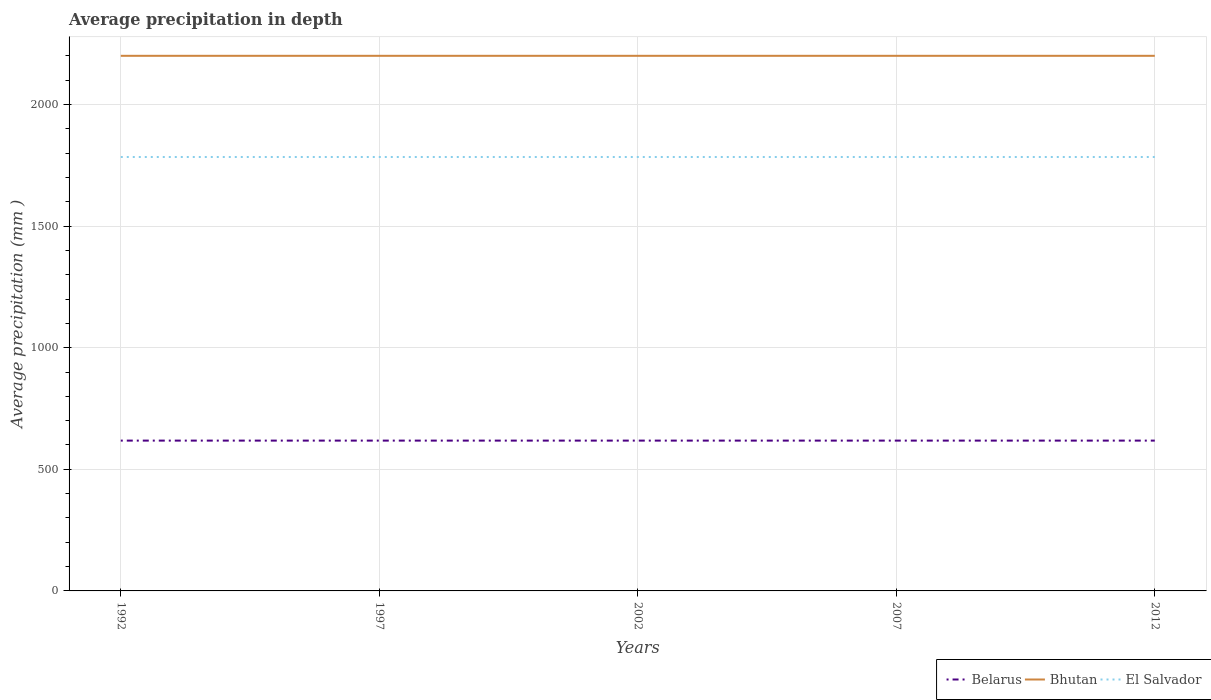Across all years, what is the maximum average precipitation in El Salvador?
Ensure brevity in your answer.  1784. What is the total average precipitation in Belarus in the graph?
Make the answer very short. 0. Is the average precipitation in El Salvador strictly greater than the average precipitation in Belarus over the years?
Your response must be concise. No. How many years are there in the graph?
Give a very brief answer. 5. What is the difference between two consecutive major ticks on the Y-axis?
Offer a terse response. 500. Are the values on the major ticks of Y-axis written in scientific E-notation?
Offer a very short reply. No. How many legend labels are there?
Your response must be concise. 3. How are the legend labels stacked?
Offer a very short reply. Horizontal. What is the title of the graph?
Keep it short and to the point. Average precipitation in depth. Does "Turkey" appear as one of the legend labels in the graph?
Your answer should be compact. No. What is the label or title of the X-axis?
Keep it short and to the point. Years. What is the label or title of the Y-axis?
Offer a very short reply. Average precipitation (mm ). What is the Average precipitation (mm ) of Belarus in 1992?
Offer a terse response. 618. What is the Average precipitation (mm ) of Bhutan in 1992?
Give a very brief answer. 2200. What is the Average precipitation (mm ) of El Salvador in 1992?
Provide a succinct answer. 1784. What is the Average precipitation (mm ) in Belarus in 1997?
Give a very brief answer. 618. What is the Average precipitation (mm ) in Bhutan in 1997?
Offer a very short reply. 2200. What is the Average precipitation (mm ) of El Salvador in 1997?
Ensure brevity in your answer.  1784. What is the Average precipitation (mm ) in Belarus in 2002?
Offer a terse response. 618. What is the Average precipitation (mm ) of Bhutan in 2002?
Your answer should be very brief. 2200. What is the Average precipitation (mm ) of El Salvador in 2002?
Make the answer very short. 1784. What is the Average precipitation (mm ) of Belarus in 2007?
Your answer should be compact. 618. What is the Average precipitation (mm ) in Bhutan in 2007?
Your answer should be very brief. 2200. What is the Average precipitation (mm ) in El Salvador in 2007?
Keep it short and to the point. 1784. What is the Average precipitation (mm ) of Belarus in 2012?
Offer a very short reply. 618. What is the Average precipitation (mm ) of Bhutan in 2012?
Your response must be concise. 2200. What is the Average precipitation (mm ) in El Salvador in 2012?
Provide a short and direct response. 1784. Across all years, what is the maximum Average precipitation (mm ) of Belarus?
Make the answer very short. 618. Across all years, what is the maximum Average precipitation (mm ) of Bhutan?
Keep it short and to the point. 2200. Across all years, what is the maximum Average precipitation (mm ) of El Salvador?
Offer a very short reply. 1784. Across all years, what is the minimum Average precipitation (mm ) of Belarus?
Your answer should be very brief. 618. Across all years, what is the minimum Average precipitation (mm ) of Bhutan?
Offer a very short reply. 2200. Across all years, what is the minimum Average precipitation (mm ) in El Salvador?
Give a very brief answer. 1784. What is the total Average precipitation (mm ) in Belarus in the graph?
Ensure brevity in your answer.  3090. What is the total Average precipitation (mm ) of Bhutan in the graph?
Give a very brief answer. 1.10e+04. What is the total Average precipitation (mm ) in El Salvador in the graph?
Ensure brevity in your answer.  8920. What is the difference between the Average precipitation (mm ) of Belarus in 1992 and that in 1997?
Your answer should be compact. 0. What is the difference between the Average precipitation (mm ) of Bhutan in 1992 and that in 1997?
Provide a short and direct response. 0. What is the difference between the Average precipitation (mm ) in Belarus in 1992 and that in 2002?
Your answer should be compact. 0. What is the difference between the Average precipitation (mm ) of El Salvador in 1992 and that in 2002?
Give a very brief answer. 0. What is the difference between the Average precipitation (mm ) in Belarus in 1992 and that in 2007?
Ensure brevity in your answer.  0. What is the difference between the Average precipitation (mm ) in El Salvador in 1992 and that in 2007?
Provide a succinct answer. 0. What is the difference between the Average precipitation (mm ) of El Salvador in 1992 and that in 2012?
Provide a succinct answer. 0. What is the difference between the Average precipitation (mm ) in El Salvador in 1997 and that in 2007?
Give a very brief answer. 0. What is the difference between the Average precipitation (mm ) in Belarus in 1997 and that in 2012?
Your answer should be very brief. 0. What is the difference between the Average precipitation (mm ) of El Salvador in 1997 and that in 2012?
Make the answer very short. 0. What is the difference between the Average precipitation (mm ) in Bhutan in 2002 and that in 2007?
Give a very brief answer. 0. What is the difference between the Average precipitation (mm ) of El Salvador in 2002 and that in 2007?
Your response must be concise. 0. What is the difference between the Average precipitation (mm ) in Belarus in 2002 and that in 2012?
Your answer should be compact. 0. What is the difference between the Average precipitation (mm ) in Bhutan in 2002 and that in 2012?
Your answer should be compact. 0. What is the difference between the Average precipitation (mm ) in Bhutan in 2007 and that in 2012?
Make the answer very short. 0. What is the difference between the Average precipitation (mm ) in El Salvador in 2007 and that in 2012?
Make the answer very short. 0. What is the difference between the Average precipitation (mm ) in Belarus in 1992 and the Average precipitation (mm ) in Bhutan in 1997?
Offer a terse response. -1582. What is the difference between the Average precipitation (mm ) of Belarus in 1992 and the Average precipitation (mm ) of El Salvador in 1997?
Give a very brief answer. -1166. What is the difference between the Average precipitation (mm ) of Bhutan in 1992 and the Average precipitation (mm ) of El Salvador in 1997?
Provide a short and direct response. 416. What is the difference between the Average precipitation (mm ) of Belarus in 1992 and the Average precipitation (mm ) of Bhutan in 2002?
Offer a terse response. -1582. What is the difference between the Average precipitation (mm ) of Belarus in 1992 and the Average precipitation (mm ) of El Salvador in 2002?
Provide a succinct answer. -1166. What is the difference between the Average precipitation (mm ) in Bhutan in 1992 and the Average precipitation (mm ) in El Salvador in 2002?
Your answer should be very brief. 416. What is the difference between the Average precipitation (mm ) of Belarus in 1992 and the Average precipitation (mm ) of Bhutan in 2007?
Your answer should be very brief. -1582. What is the difference between the Average precipitation (mm ) of Belarus in 1992 and the Average precipitation (mm ) of El Salvador in 2007?
Give a very brief answer. -1166. What is the difference between the Average precipitation (mm ) in Bhutan in 1992 and the Average precipitation (mm ) in El Salvador in 2007?
Provide a succinct answer. 416. What is the difference between the Average precipitation (mm ) in Belarus in 1992 and the Average precipitation (mm ) in Bhutan in 2012?
Make the answer very short. -1582. What is the difference between the Average precipitation (mm ) of Belarus in 1992 and the Average precipitation (mm ) of El Salvador in 2012?
Your response must be concise. -1166. What is the difference between the Average precipitation (mm ) of Bhutan in 1992 and the Average precipitation (mm ) of El Salvador in 2012?
Your answer should be very brief. 416. What is the difference between the Average precipitation (mm ) in Belarus in 1997 and the Average precipitation (mm ) in Bhutan in 2002?
Keep it short and to the point. -1582. What is the difference between the Average precipitation (mm ) in Belarus in 1997 and the Average precipitation (mm ) in El Salvador in 2002?
Make the answer very short. -1166. What is the difference between the Average precipitation (mm ) in Bhutan in 1997 and the Average precipitation (mm ) in El Salvador in 2002?
Provide a short and direct response. 416. What is the difference between the Average precipitation (mm ) in Belarus in 1997 and the Average precipitation (mm ) in Bhutan in 2007?
Provide a succinct answer. -1582. What is the difference between the Average precipitation (mm ) in Belarus in 1997 and the Average precipitation (mm ) in El Salvador in 2007?
Provide a succinct answer. -1166. What is the difference between the Average precipitation (mm ) of Bhutan in 1997 and the Average precipitation (mm ) of El Salvador in 2007?
Provide a short and direct response. 416. What is the difference between the Average precipitation (mm ) of Belarus in 1997 and the Average precipitation (mm ) of Bhutan in 2012?
Make the answer very short. -1582. What is the difference between the Average precipitation (mm ) in Belarus in 1997 and the Average precipitation (mm ) in El Salvador in 2012?
Provide a succinct answer. -1166. What is the difference between the Average precipitation (mm ) in Bhutan in 1997 and the Average precipitation (mm ) in El Salvador in 2012?
Offer a very short reply. 416. What is the difference between the Average precipitation (mm ) in Belarus in 2002 and the Average precipitation (mm ) in Bhutan in 2007?
Your answer should be very brief. -1582. What is the difference between the Average precipitation (mm ) of Belarus in 2002 and the Average precipitation (mm ) of El Salvador in 2007?
Your answer should be compact. -1166. What is the difference between the Average precipitation (mm ) of Bhutan in 2002 and the Average precipitation (mm ) of El Salvador in 2007?
Give a very brief answer. 416. What is the difference between the Average precipitation (mm ) of Belarus in 2002 and the Average precipitation (mm ) of Bhutan in 2012?
Offer a very short reply. -1582. What is the difference between the Average precipitation (mm ) in Belarus in 2002 and the Average precipitation (mm ) in El Salvador in 2012?
Your response must be concise. -1166. What is the difference between the Average precipitation (mm ) in Bhutan in 2002 and the Average precipitation (mm ) in El Salvador in 2012?
Your response must be concise. 416. What is the difference between the Average precipitation (mm ) of Belarus in 2007 and the Average precipitation (mm ) of Bhutan in 2012?
Your answer should be very brief. -1582. What is the difference between the Average precipitation (mm ) in Belarus in 2007 and the Average precipitation (mm ) in El Salvador in 2012?
Offer a very short reply. -1166. What is the difference between the Average precipitation (mm ) in Bhutan in 2007 and the Average precipitation (mm ) in El Salvador in 2012?
Ensure brevity in your answer.  416. What is the average Average precipitation (mm ) of Belarus per year?
Provide a short and direct response. 618. What is the average Average precipitation (mm ) in Bhutan per year?
Provide a short and direct response. 2200. What is the average Average precipitation (mm ) of El Salvador per year?
Make the answer very short. 1784. In the year 1992, what is the difference between the Average precipitation (mm ) of Belarus and Average precipitation (mm ) of Bhutan?
Your response must be concise. -1582. In the year 1992, what is the difference between the Average precipitation (mm ) in Belarus and Average precipitation (mm ) in El Salvador?
Give a very brief answer. -1166. In the year 1992, what is the difference between the Average precipitation (mm ) of Bhutan and Average precipitation (mm ) of El Salvador?
Provide a short and direct response. 416. In the year 1997, what is the difference between the Average precipitation (mm ) of Belarus and Average precipitation (mm ) of Bhutan?
Provide a succinct answer. -1582. In the year 1997, what is the difference between the Average precipitation (mm ) in Belarus and Average precipitation (mm ) in El Salvador?
Your answer should be very brief. -1166. In the year 1997, what is the difference between the Average precipitation (mm ) of Bhutan and Average precipitation (mm ) of El Salvador?
Ensure brevity in your answer.  416. In the year 2002, what is the difference between the Average precipitation (mm ) of Belarus and Average precipitation (mm ) of Bhutan?
Offer a terse response. -1582. In the year 2002, what is the difference between the Average precipitation (mm ) of Belarus and Average precipitation (mm ) of El Salvador?
Make the answer very short. -1166. In the year 2002, what is the difference between the Average precipitation (mm ) in Bhutan and Average precipitation (mm ) in El Salvador?
Make the answer very short. 416. In the year 2007, what is the difference between the Average precipitation (mm ) in Belarus and Average precipitation (mm ) in Bhutan?
Keep it short and to the point. -1582. In the year 2007, what is the difference between the Average precipitation (mm ) of Belarus and Average precipitation (mm ) of El Salvador?
Offer a very short reply. -1166. In the year 2007, what is the difference between the Average precipitation (mm ) in Bhutan and Average precipitation (mm ) in El Salvador?
Provide a short and direct response. 416. In the year 2012, what is the difference between the Average precipitation (mm ) in Belarus and Average precipitation (mm ) in Bhutan?
Make the answer very short. -1582. In the year 2012, what is the difference between the Average precipitation (mm ) in Belarus and Average precipitation (mm ) in El Salvador?
Offer a very short reply. -1166. In the year 2012, what is the difference between the Average precipitation (mm ) in Bhutan and Average precipitation (mm ) in El Salvador?
Your response must be concise. 416. What is the ratio of the Average precipitation (mm ) of Bhutan in 1992 to that in 1997?
Ensure brevity in your answer.  1. What is the ratio of the Average precipitation (mm ) in El Salvador in 1992 to that in 1997?
Provide a succinct answer. 1. What is the ratio of the Average precipitation (mm ) in Belarus in 1992 to that in 2002?
Your answer should be compact. 1. What is the ratio of the Average precipitation (mm ) of Bhutan in 1992 to that in 2002?
Make the answer very short. 1. What is the ratio of the Average precipitation (mm ) of El Salvador in 1992 to that in 2002?
Ensure brevity in your answer.  1. What is the ratio of the Average precipitation (mm ) of Bhutan in 1992 to that in 2007?
Offer a very short reply. 1. What is the ratio of the Average precipitation (mm ) in Belarus in 1992 to that in 2012?
Keep it short and to the point. 1. What is the ratio of the Average precipitation (mm ) in El Salvador in 1997 to that in 2002?
Provide a succinct answer. 1. What is the ratio of the Average precipitation (mm ) of Belarus in 1997 to that in 2007?
Your answer should be very brief. 1. What is the ratio of the Average precipitation (mm ) in Bhutan in 1997 to that in 2007?
Ensure brevity in your answer.  1. What is the ratio of the Average precipitation (mm ) in El Salvador in 1997 to that in 2007?
Your answer should be compact. 1. What is the ratio of the Average precipitation (mm ) in Belarus in 1997 to that in 2012?
Keep it short and to the point. 1. What is the ratio of the Average precipitation (mm ) of Bhutan in 2002 to that in 2012?
Give a very brief answer. 1. What is the ratio of the Average precipitation (mm ) in El Salvador in 2002 to that in 2012?
Provide a succinct answer. 1. What is the ratio of the Average precipitation (mm ) in Belarus in 2007 to that in 2012?
Keep it short and to the point. 1. What is the ratio of the Average precipitation (mm ) of El Salvador in 2007 to that in 2012?
Ensure brevity in your answer.  1. What is the difference between the highest and the second highest Average precipitation (mm ) of Belarus?
Keep it short and to the point. 0. What is the difference between the highest and the second highest Average precipitation (mm ) of Bhutan?
Provide a short and direct response. 0. What is the difference between the highest and the lowest Average precipitation (mm ) of Bhutan?
Keep it short and to the point. 0. What is the difference between the highest and the lowest Average precipitation (mm ) of El Salvador?
Provide a succinct answer. 0. 